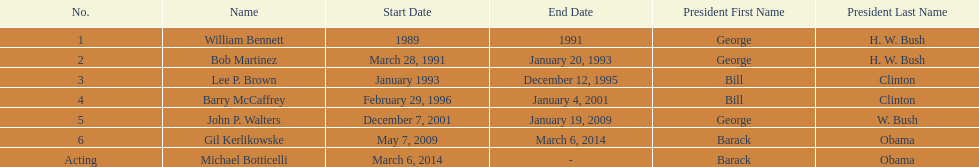Who serves inder barack obama? Gil Kerlikowske. 